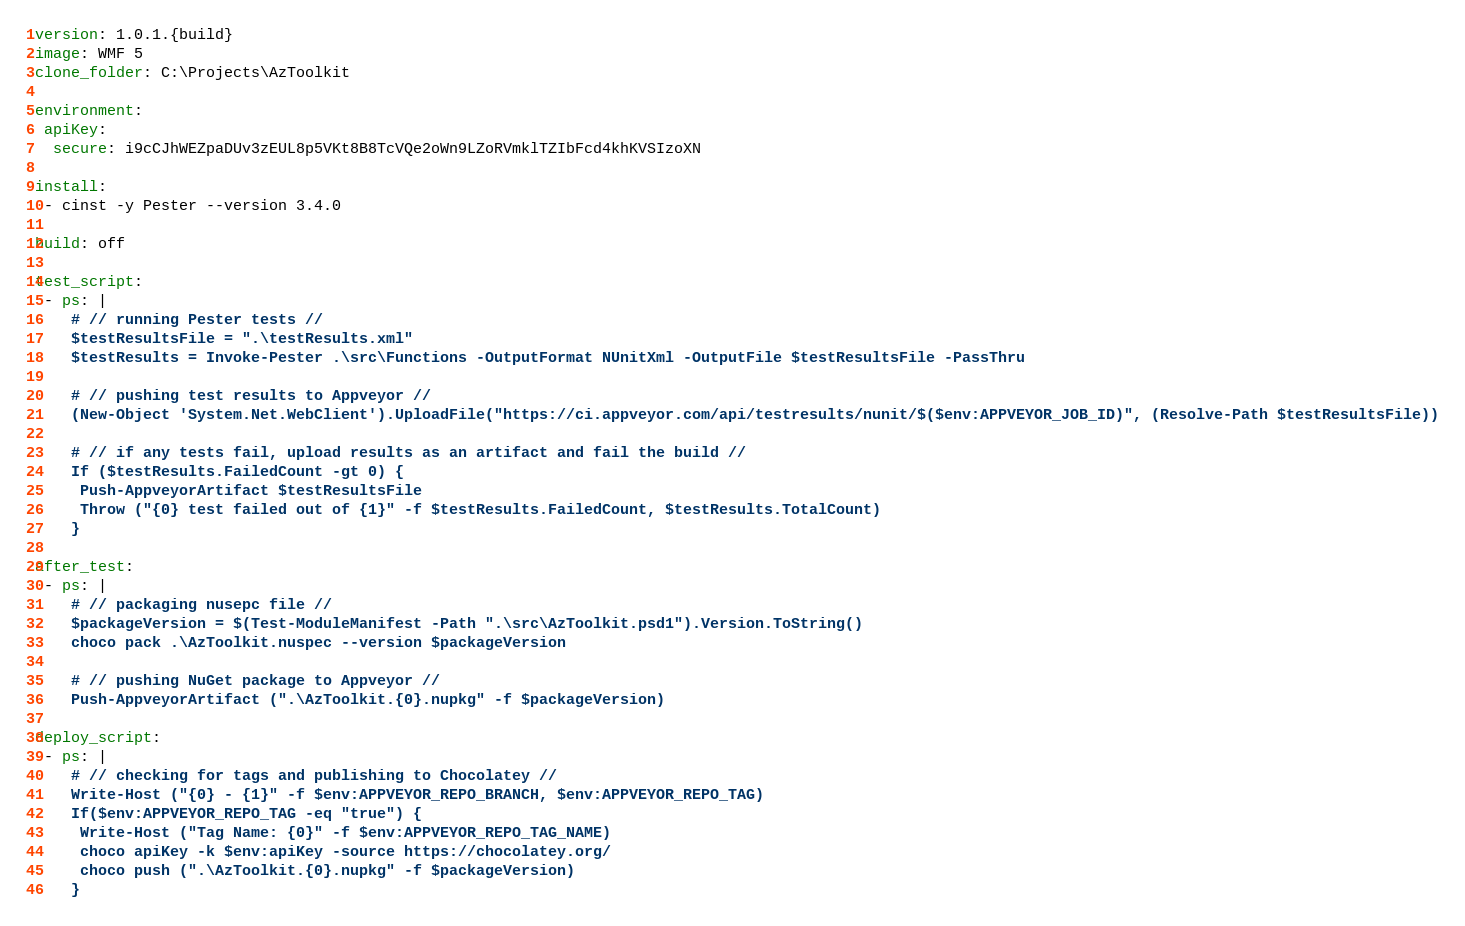<code> <loc_0><loc_0><loc_500><loc_500><_YAML_>version: 1.0.1.{build}
image: WMF 5
clone_folder: C:\Projects\AzToolkit

environment:
 apiKey:
  secure: i9cCJhWEZpaDUv3zEUL8p5VKt8B8TcVQe2oWn9LZoRVmklTZIbFcd4khKVSIzoXN

install:
 - cinst -y Pester --version 3.4.0

build: off

test_script:
 - ps: |
    # // running Pester tests //
    $testResultsFile = ".\testResults.xml"
    $testResults = Invoke-Pester .\src\Functions -OutputFormat NUnitXml -OutputFile $testResultsFile -PassThru

    # // pushing test results to Appveyor //
    (New-Object 'System.Net.WebClient').UploadFile("https://ci.appveyor.com/api/testresults/nunit/$($env:APPVEYOR_JOB_ID)", (Resolve-Path $testResultsFile))

    # // if any tests fail, upload results as an artifact and fail the build //
    If ($testResults.FailedCount -gt 0) {
     Push-AppveyorArtifact $testResultsFile
     Throw ("{0} test failed out of {1}" -f $testResults.FailedCount, $testResults.TotalCount)
    }

after_test:
 - ps: |
    # // packaging nusepc file //
    $packageVersion = $(Test-ModuleManifest -Path ".\src\AzToolkit.psd1").Version.ToString()
    choco pack .\AzToolkit.nuspec --version $packageVersion

    # // pushing NuGet package to Appveyor //
    Push-AppveyorArtifact (".\AzToolkit.{0}.nupkg" -f $packageVersion)

deploy_script:
 - ps: |
    # // checking for tags and publishing to Chocolatey //
    Write-Host ("{0} - {1}" -f $env:APPVEYOR_REPO_BRANCH, $env:APPVEYOR_REPO_TAG)
    If($env:APPVEYOR_REPO_TAG -eq "true") {
     Write-Host ("Tag Name: {0}" -f $env:APPVEYOR_REPO_TAG_NAME)
     choco apiKey -k $env:apiKey -source https://chocolatey.org/
     choco push (".\AzToolkit.{0}.nupkg" -f $packageVersion)
    }
</code> 